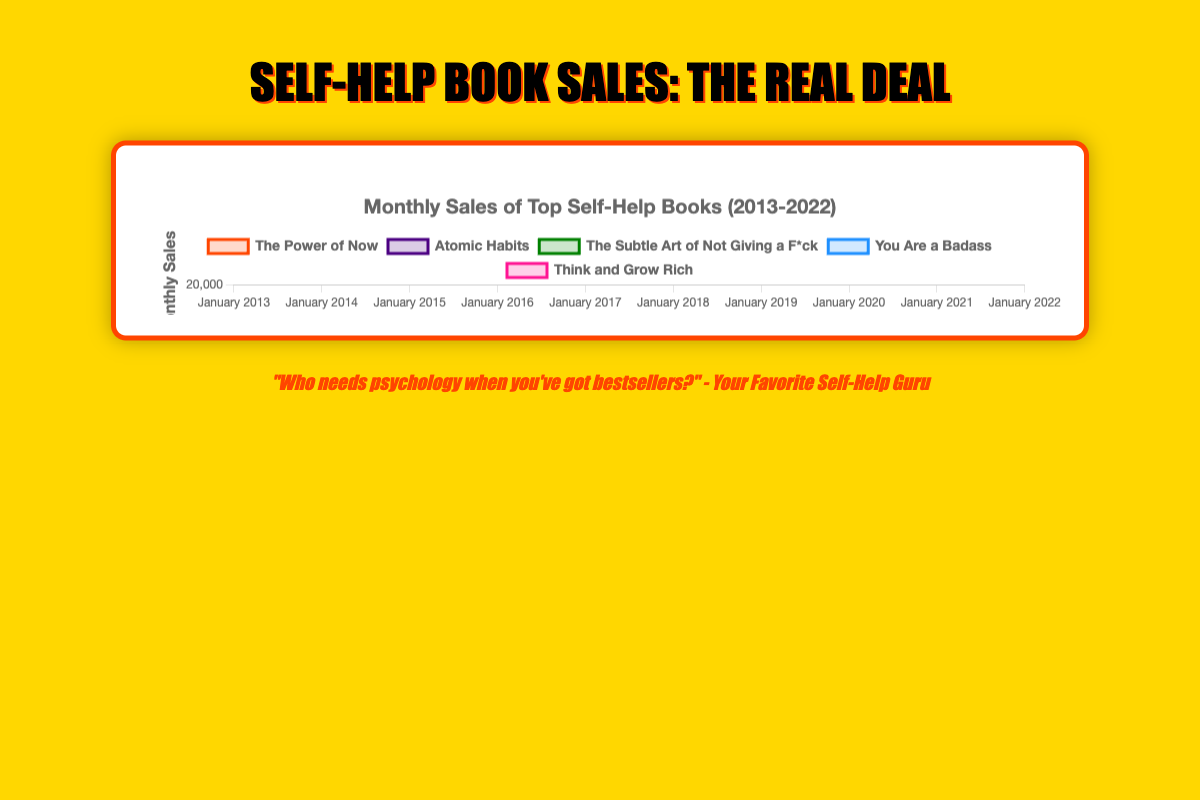Which book has the highest monthly sales in January 2022? Among the lines on the chart, identify the one reaching the highest point in January 2022. The book "The Power of Now" by Eckhart Tolle has the highest position.
Answer: The Power of Now How do the monthly sales in January 2018 of "Atomic Habits" and "Think and Grow Rich" compare? On the chart, find the points corresponding to January 2018 for both books. "Atomic Habits" has a higher value compared to "Think and Grow Rich".
Answer: Atomic Habits > Think and Grow Rich By how much did the sales of "The Subtle Art of Not Giving a F*ck" increase from January 2013 to January 2020? Identify the points representing January 2013 and January 2020 for "The Subtle Art of Not Giving a F*ck". The values are 24000 and 31000 respectively. Subtract 24000 from 31000 to get the increase.
Answer: 7000 What is the average monthly sales in January 2020 across all books? Sum up the sales figures for January 2020 for all books, which are: 42000 + 32000 + 31000 + 30000 + 29000. Divide the total by 5. (42000+32000+31000+30000+29000) / 5 = 32000.
Answer: 32000 Which book shows the most significant sales increase over the entire decade? Compare the slope of each line from January 2013 to January 2022. "The Power of Now" shows the steepest line, indicating the most significant increase.
Answer: The Power of Now How did the sales of "You Are a Badass" change from January 2015 to January 2016? Look at the chart and find the points for "You Are a Badass" in January 2015 and January 2016. The sales increased from 25000 to 26000. The difference is 26000 - 25000 = 1000.
Answer: Increased by 1000 Which book had the lowest monthly sales in January 2013? On the chart, identify the book with the lowest point in January 2013. "Think and Grow Rich" is the one with the lowest sales.
Answer: Think and Grow Rich What is the overall trend of "The Subtle Art of Not Giving a F*ck" from 2013 to 2022? Observe the chart line for "The Subtle Art of Not Giving a F*ck" from 2013 to 2022. The line consistently trends upwards.
Answer: Increasing 